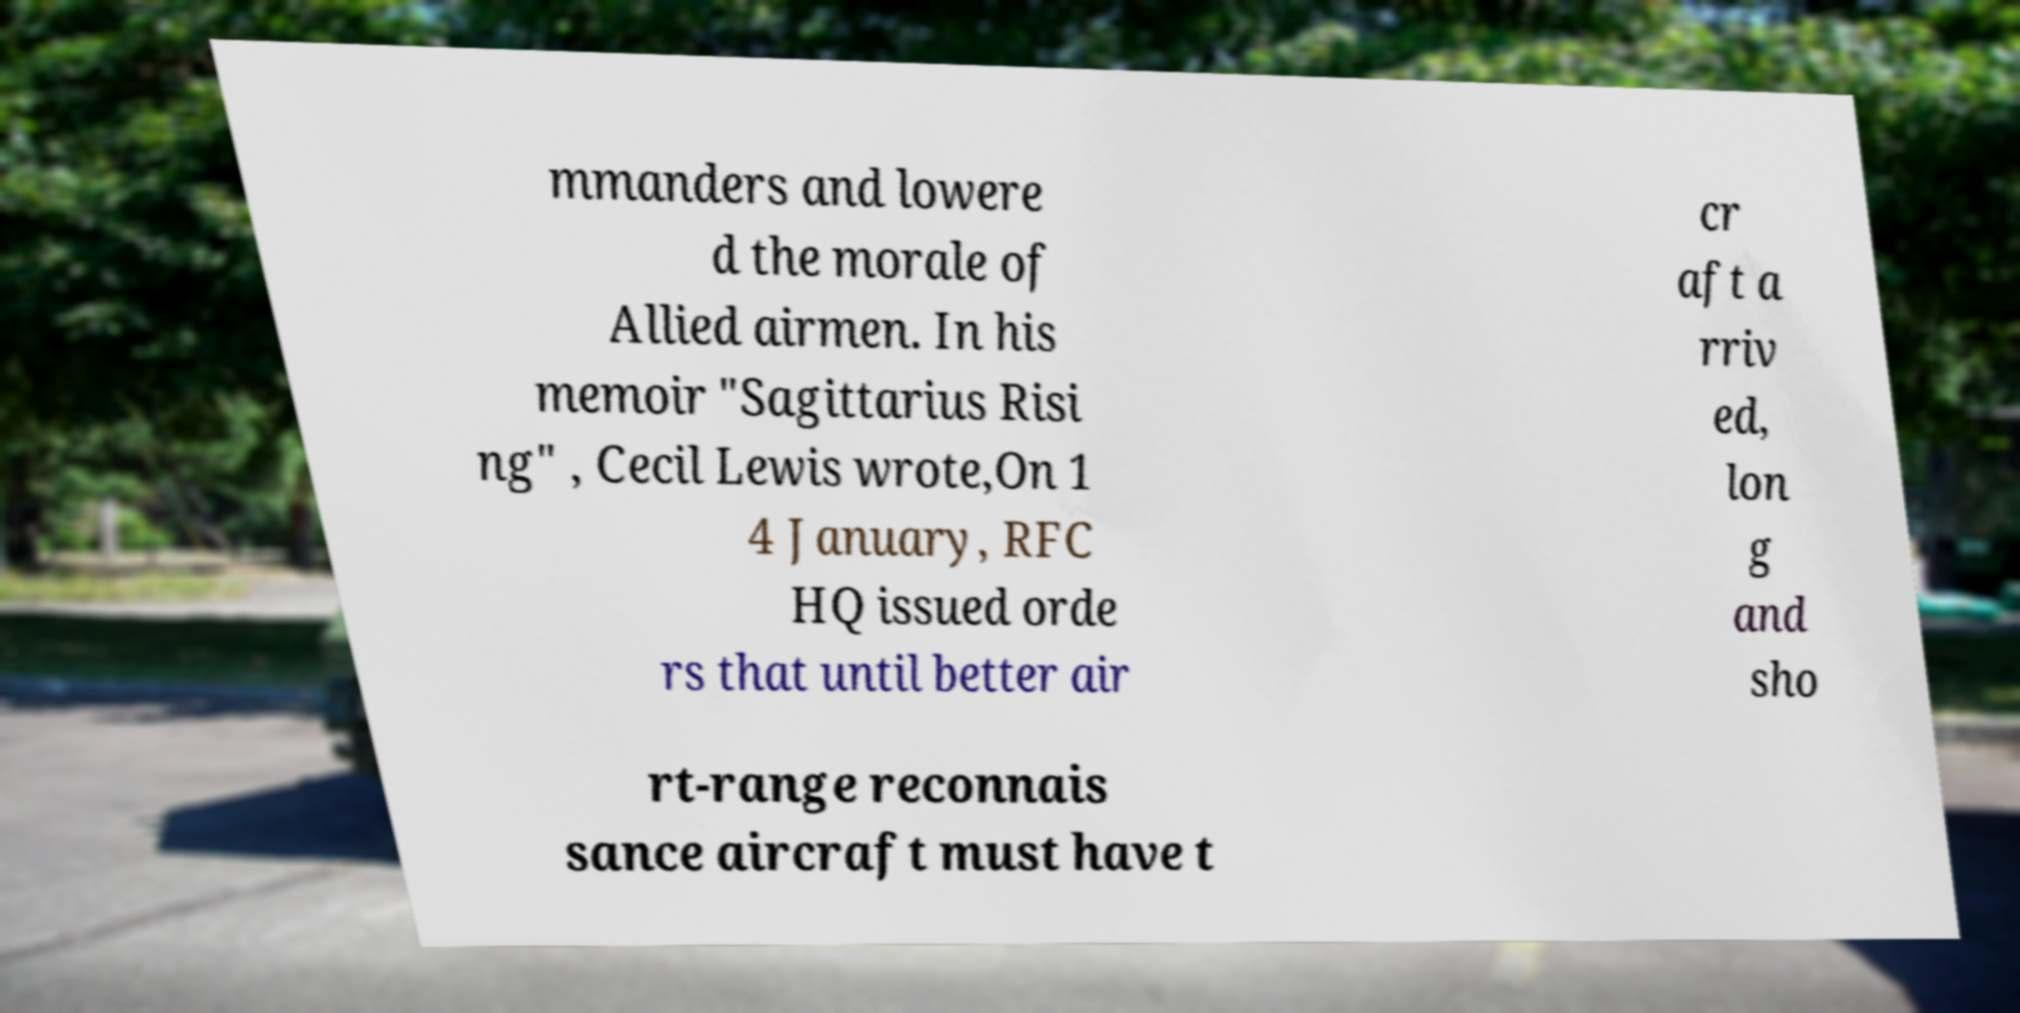Could you assist in decoding the text presented in this image and type it out clearly? mmanders and lowere d the morale of Allied airmen. In his memoir "Sagittarius Risi ng" , Cecil Lewis wrote,On 1 4 January, RFC HQ issued orde rs that until better air cr aft a rriv ed, lon g and sho rt-range reconnais sance aircraft must have t 